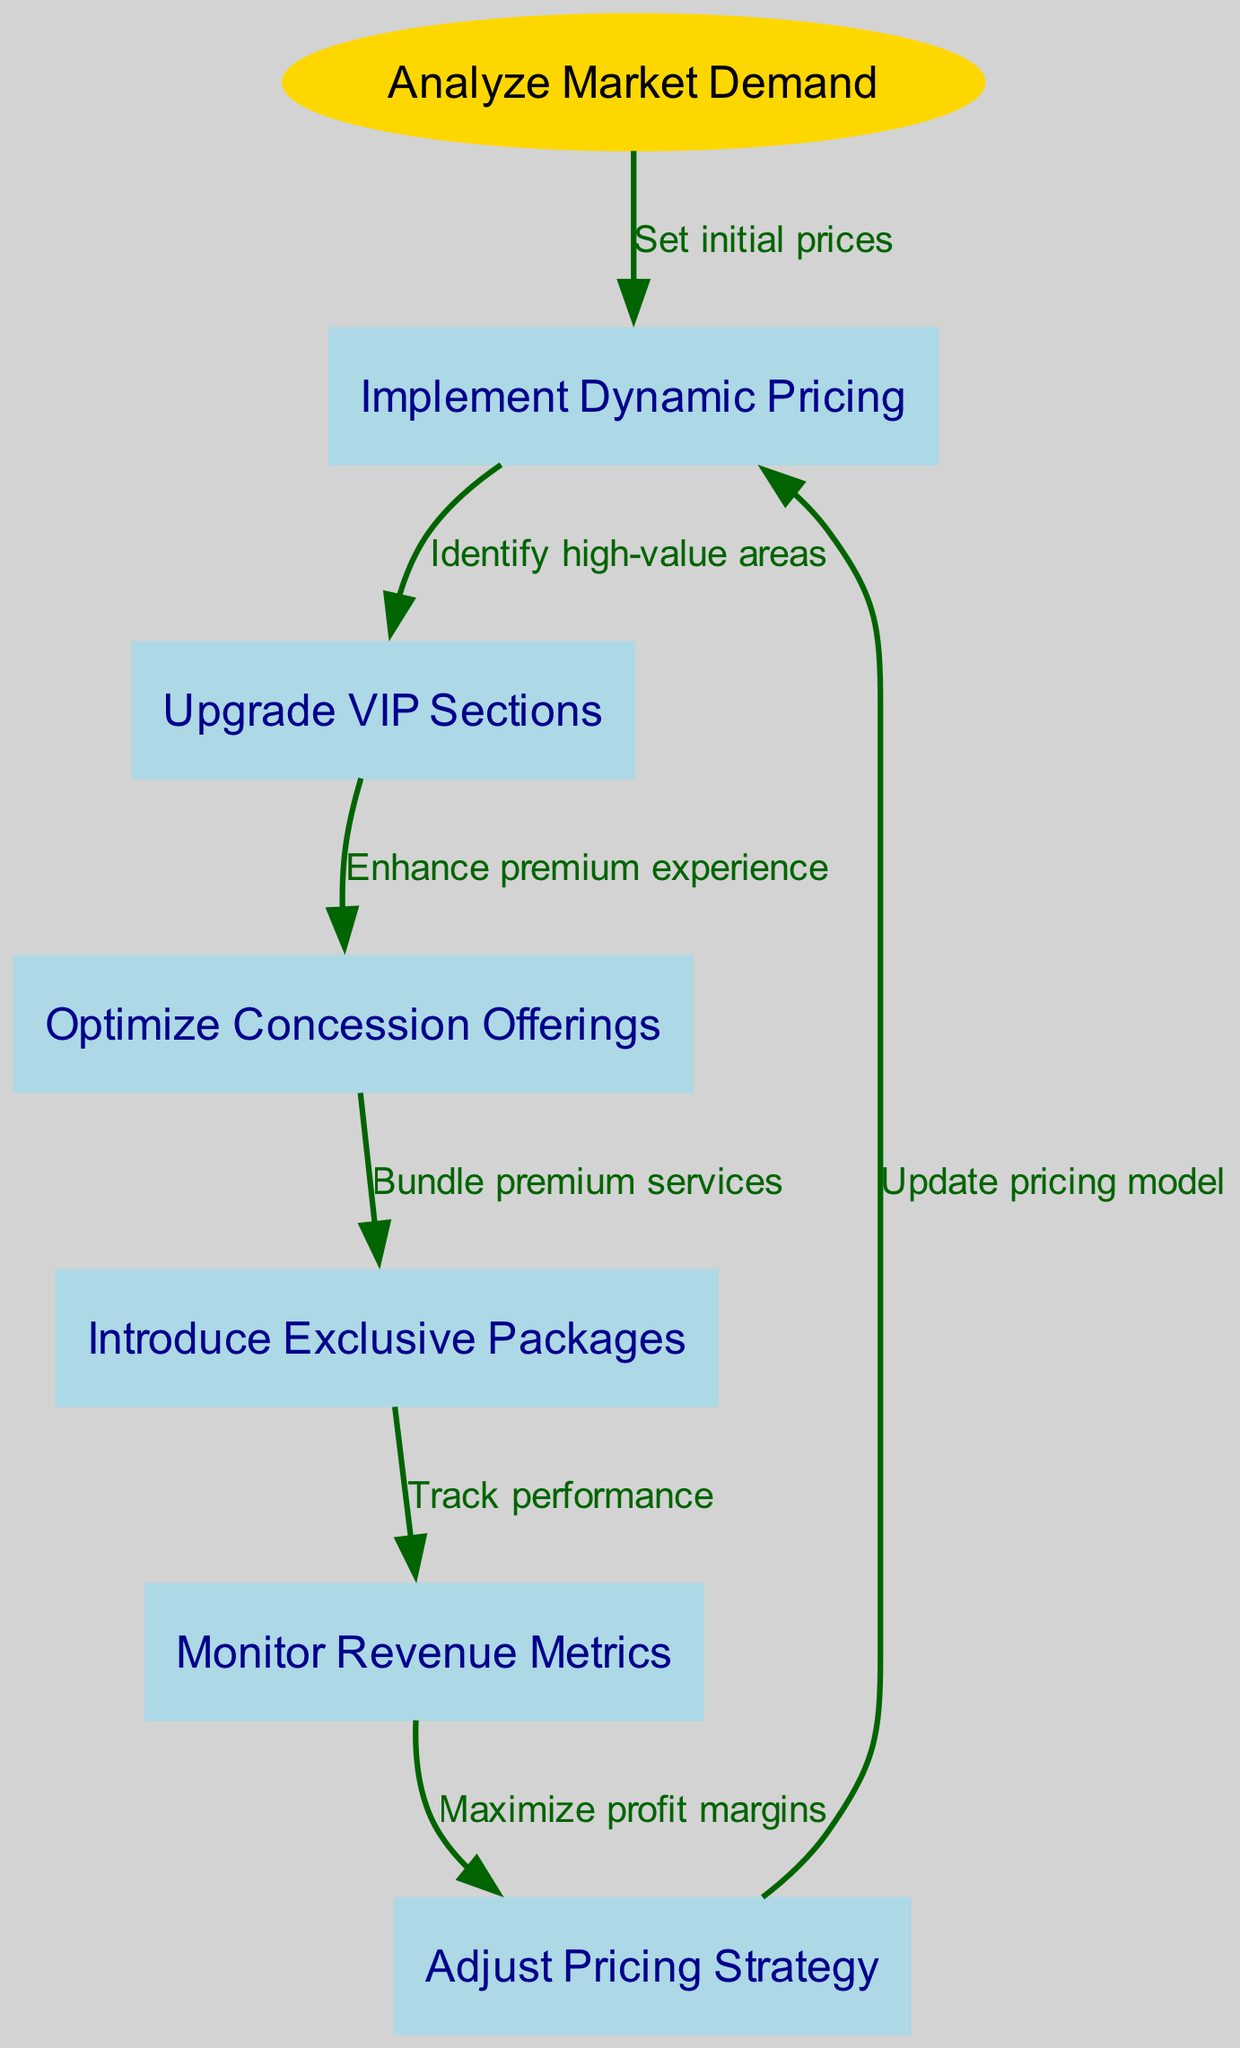What is the starting node of the flow chart? The starting node is indicated as the first node in the diagram, labeled "Analyze Market Demand."
Answer: Analyze Market Demand How many total nodes are there in the diagram? By counting all the nodes listed including the start node, we find there are a total of seven nodes.
Answer: 7 What is the first edge leading from the starting node? The first edge leads from "Analyze Market Demand" to "Implement Dynamic Pricing," labeled "Set initial prices."
Answer: Set initial prices What node comes after "Introduce Exclusive Packages"? Following "Introduce Exclusive Packages," the next node in the flow is "Monitor Revenue Metrics."
Answer: Monitor Revenue Metrics What label is used on the edge between "Monitor Revenue Metrics" and "Adjust Pricing Strategy"? The label on the edge connecting these two nodes indicates the action or purpose of the connection, which is "Maximize profit margins."
Answer: Maximize profit margins What does "Upgrade VIP Sections" lead to? The node "Upgrade VIP Sections" directly leads to "Optimize Concession Offerings," as indicated in the flow chart.
Answer: Optimize Concession Offerings Which node is considered a looping point in the diagram? The looping point occurs at the edge from "Adjust Pricing Strategy" back to "Implement Dynamic Pricing," allowing for continuous adjustment.
Answer: Implement Dynamic Pricing How does "Optimize Concession Offerings" relate to "Introduce Exclusive Packages"? "Optimize Concession Offerings" leads directly to "Introduce Exclusive Packages," suggesting that concessions are bundled with premium services following optimization.
Answer: Introduce Exclusive Packages What indicates high-value areas in the flow? The action to "Identify high-value areas" occurs as a result of implementing dynamic pricing after analyzing market demand.
Answer: Identify high-value areas 